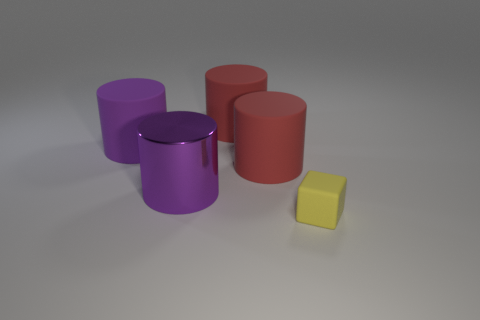There is a small block; what number of things are behind it? Behind the small yellow block, there are three cylindrical objects aligned in a manner that partially obscures each from a direct view. The foreground consists of the small block, which is distinctively smaller and a different shape compared to the cylindrical objects. 